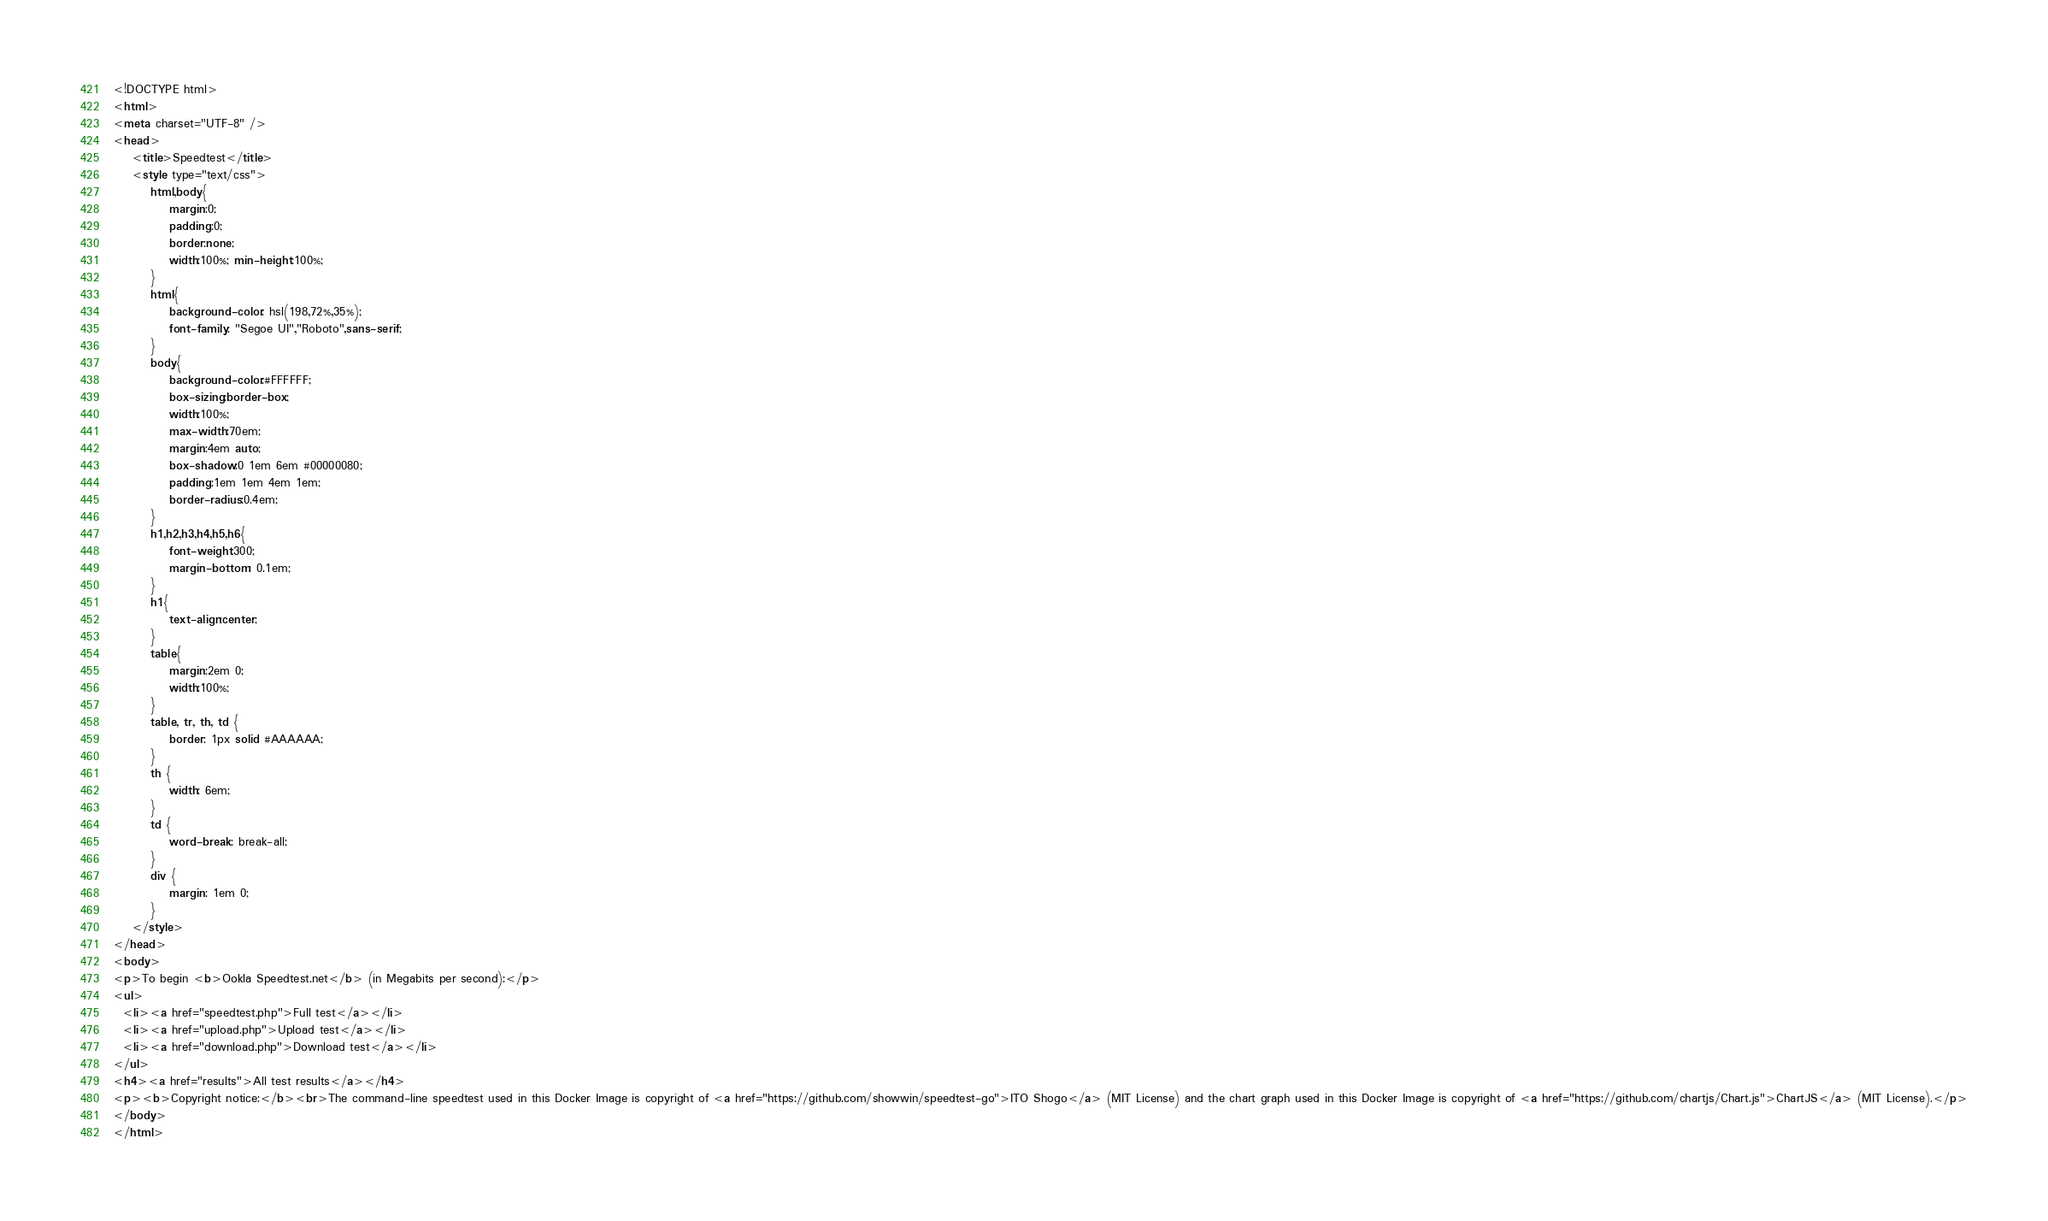<code> <loc_0><loc_0><loc_500><loc_500><_HTML_><!DOCTYPE html>
<html>
<meta charset="UTF-8" />
<head>
    <title>Speedtest</title>
	<style type="text/css">
		html,body{
			margin:0;
			padding:0;
			border:none;
			width:100%; min-height:100%;
		}
		html{
			background-color: hsl(198,72%,35%);
			font-family: "Segoe UI","Roboto",sans-serif;
		}
		body{
			background-color:#FFFFFF;
			box-sizing:border-box;
			width:100%;
			max-width:70em;
			margin:4em auto;
			box-shadow:0 1em 6em #00000080;
			padding:1em 1em 4em 1em;
			border-radius:0.4em;
		}
		h1,h2,h3,h4,h5,h6{
			font-weight:300;
			margin-bottom: 0.1em;
		}
		h1{
			text-align:center;
		}
		table{
			margin:2em 0;
			width:100%;
		}
		table, tr, th, td {
			border: 1px solid #AAAAAA;
		}
		th {
			width: 6em;
		}
		td {
			word-break: break-all;
		}
		div {
			margin: 1em 0;
		}
	</style>
</head>
<body>
<p>To begin <b>Ookla Speedtest.net</b> (in Megabits per second):</p>
<ul>
  <li><a href="speedtest.php">Full test</a></li>
  <li><a href="upload.php">Upload test</a></li>
  <li><a href="download.php">Download test</a></li>
</ul>
<h4><a href="results">All test results</a></h4>
<p><b>Copyright notice:</b><br>The command-line speedtest used in this Docker Image is copyright of <a href="https://github.com/showwin/speedtest-go">ITO Shogo</a> (MIT License) and the chart graph used in this Docker Image is copyright of <a href="https://github.com/chartjs/Chart.js">ChartJS</a> (MIT License).</p>
</body>
</html>
</code> 